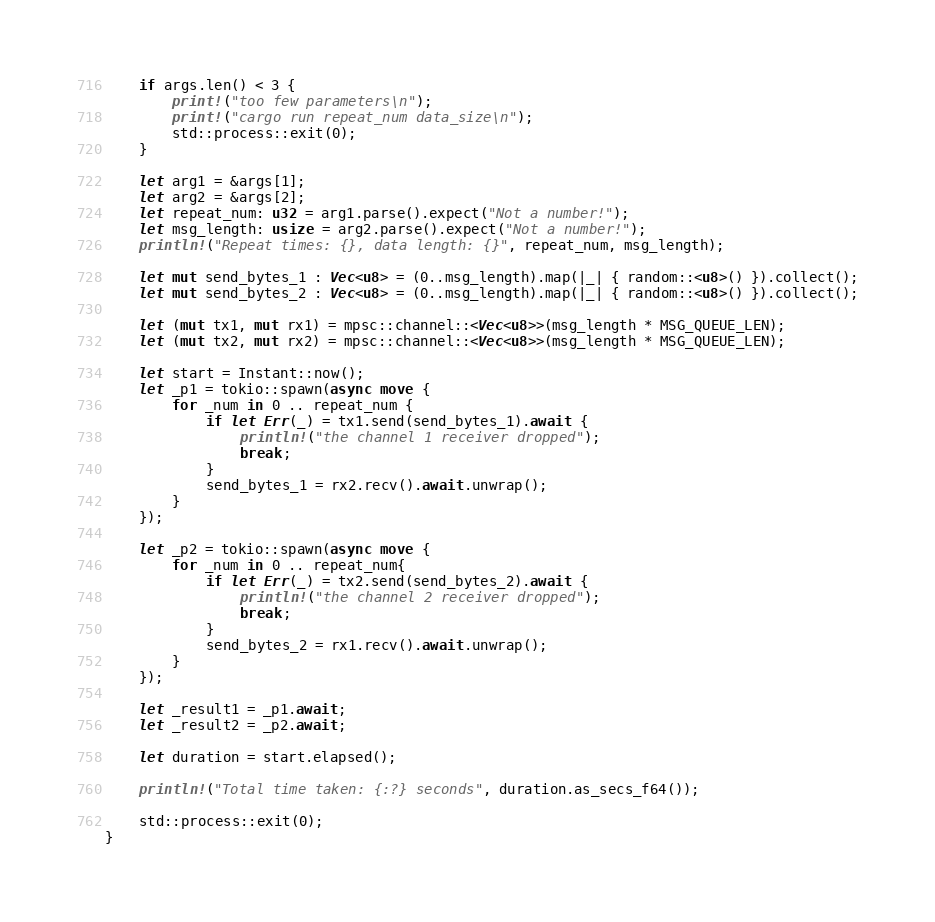Convert code to text. <code><loc_0><loc_0><loc_500><loc_500><_Rust_>    if args.len() < 3 {
        print!("too few parameters\n");
        print!("cargo run repeat_num data_size\n");
        std::process::exit(0);
    }

    let arg1 = &args[1];
    let arg2 = &args[2];
    let repeat_num: u32 = arg1.parse().expect("Not a number!");
    let msg_length: usize = arg2.parse().expect("Not a number!");
    println!("Repeat times: {}, data length: {}", repeat_num, msg_length);

    let mut send_bytes_1 : Vec<u8> = (0..msg_length).map(|_| { random::<u8>() }).collect();
    let mut send_bytes_2 : Vec<u8> = (0..msg_length).map(|_| { random::<u8>() }).collect();

    let (mut tx1, mut rx1) = mpsc::channel::<Vec<u8>>(msg_length * MSG_QUEUE_LEN);
    let (mut tx2, mut rx2) = mpsc::channel::<Vec<u8>>(msg_length * MSG_QUEUE_LEN);

    let start = Instant::now();
    let _p1 = tokio::spawn(async move {
        for _num in 0 .. repeat_num {
            if let Err(_) = tx1.send(send_bytes_1).await {
                println!("the channel 1 receiver dropped");
                break;
            }
            send_bytes_1 = rx2.recv().await.unwrap();
        }
    });

    let _p2 = tokio::spawn(async move {
        for _num in 0 .. repeat_num{
            if let Err(_) = tx2.send(send_bytes_2).await {
                println!("the channel 2 receiver dropped");
                break;
            }
            send_bytes_2 = rx1.recv().await.unwrap();
        }
    });

    let _result1 = _p1.await;
    let _result2 = _p2.await;

    let duration = start.elapsed();

    println!("Total time taken: {:?} seconds", duration.as_secs_f64());

    std::process::exit(0);
}

</code> 